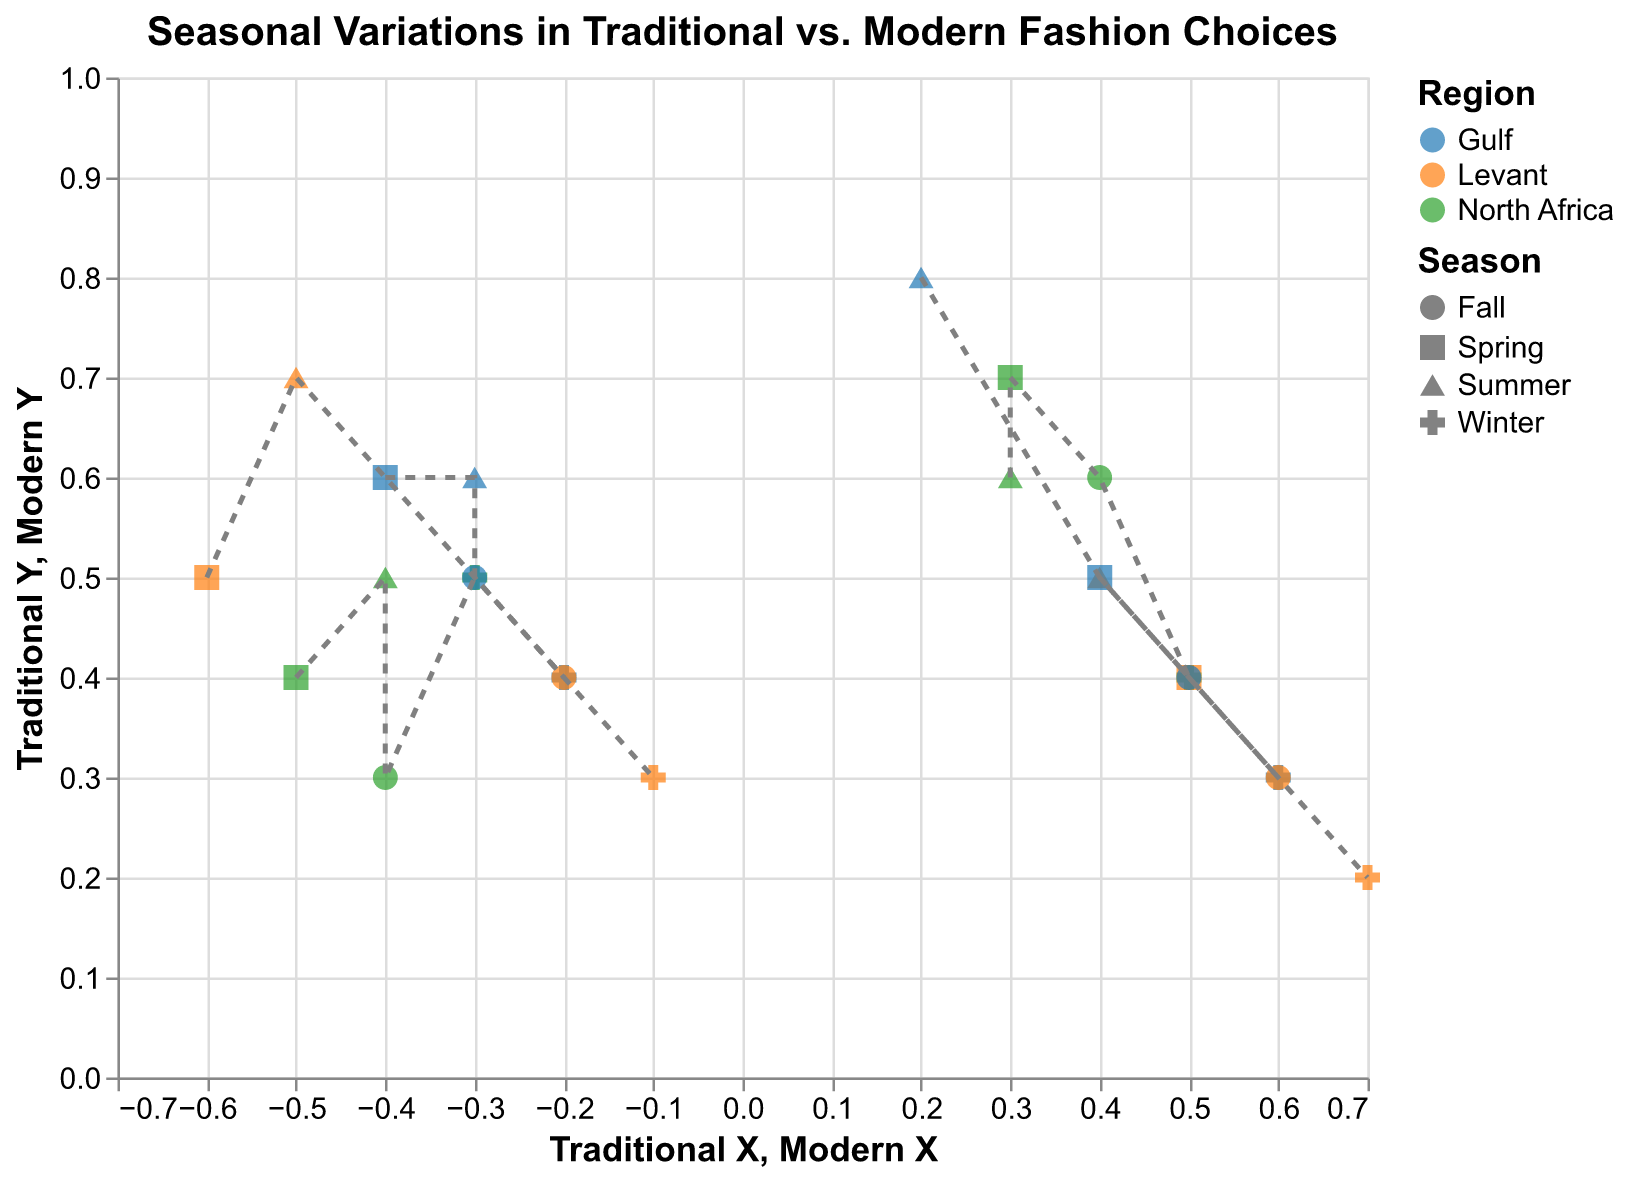What is the title of the plot? The title is located at the top of the figure and reads "Seasonal Variations in Traditional vs. Modern Fashion Choices"
Answer: Seasonal Variations in Traditional vs. Modern Fashion Choices How many regions are represented in the plot? There are three distinct colors representing the regions. They are labeled as Gulf, Levant, and North Africa.
Answer: Three In which season is the traditional fashion choice for the Gulf region the highest on the Y-axis? By looking at the Y coordinates of Traditional X for the Gulf region in each season, the highest value is in Summer with a value of 0.8
Answer: Summer How do modern fashion choices compare to traditional ones in North Africa during Fall? Comparing the coordinates for North Africa in Fall, the Traditional X is 0.4, Traditional Y is 0.6, Modern X is -0.4, and Modern Y is 0.3. Modern choices have lower values compared to traditional ones.
Answer: Modern values are lower What is the difference between Traditional Y and Modern Y in the Levant region during Winter? The coordinates for Levant in Winter are Traditional Y = 0.2 and Modern Y = 0.3. Therefore, the difference is 0.3 - 0.2 = 0.1
Answer: 0.1 Which season shows the largest change in Traditional X values for the Gulf region? Looking at the Traditional X values for the Gulf region, the seasons are Summer (0.2), Winter (0.6), Spring (0.4), Fall (0.5). The largest change is between Summer and Winter, with a difference of 0.6 - 0.2 = 0.4
Answer: Winter Compare the Modern Y values across all seasons for the Levant region. Which season has the highest value? The Modern Y values for Levant are Summer (0.7), Winter (0.3), Spring (0.5), Fall (0.4). The highest value is in Summer with 0.7
Answer: Summer What is the sum of Traditional Y values for North Africa in Summer, Winter, Spring, and Fall? The Traditional Y values for North Africa are Summer (0.6), Winter (0.4), Spring (0.7), Fall (0.6). The sum is 0.6 + 0.4 + 0.7 + 0.6 = 2.3
Answer: 2.3 Which region shows the most consistent Traditional Y values across all seasons? By comparing the Traditional Y values for all regions across seasons: Gulf (Summer 0.8, Winter 0.3, Spring 0.5, Fall 0.4), Levant (Summer 0.5, Winter 0.2, Spring 0.4, Fall 0.3), North Africa (Summer 0.6, Winter 0.4, Spring 0.7, Fall 0.6), North Africa has the most consistent values
Answer: North Africa 